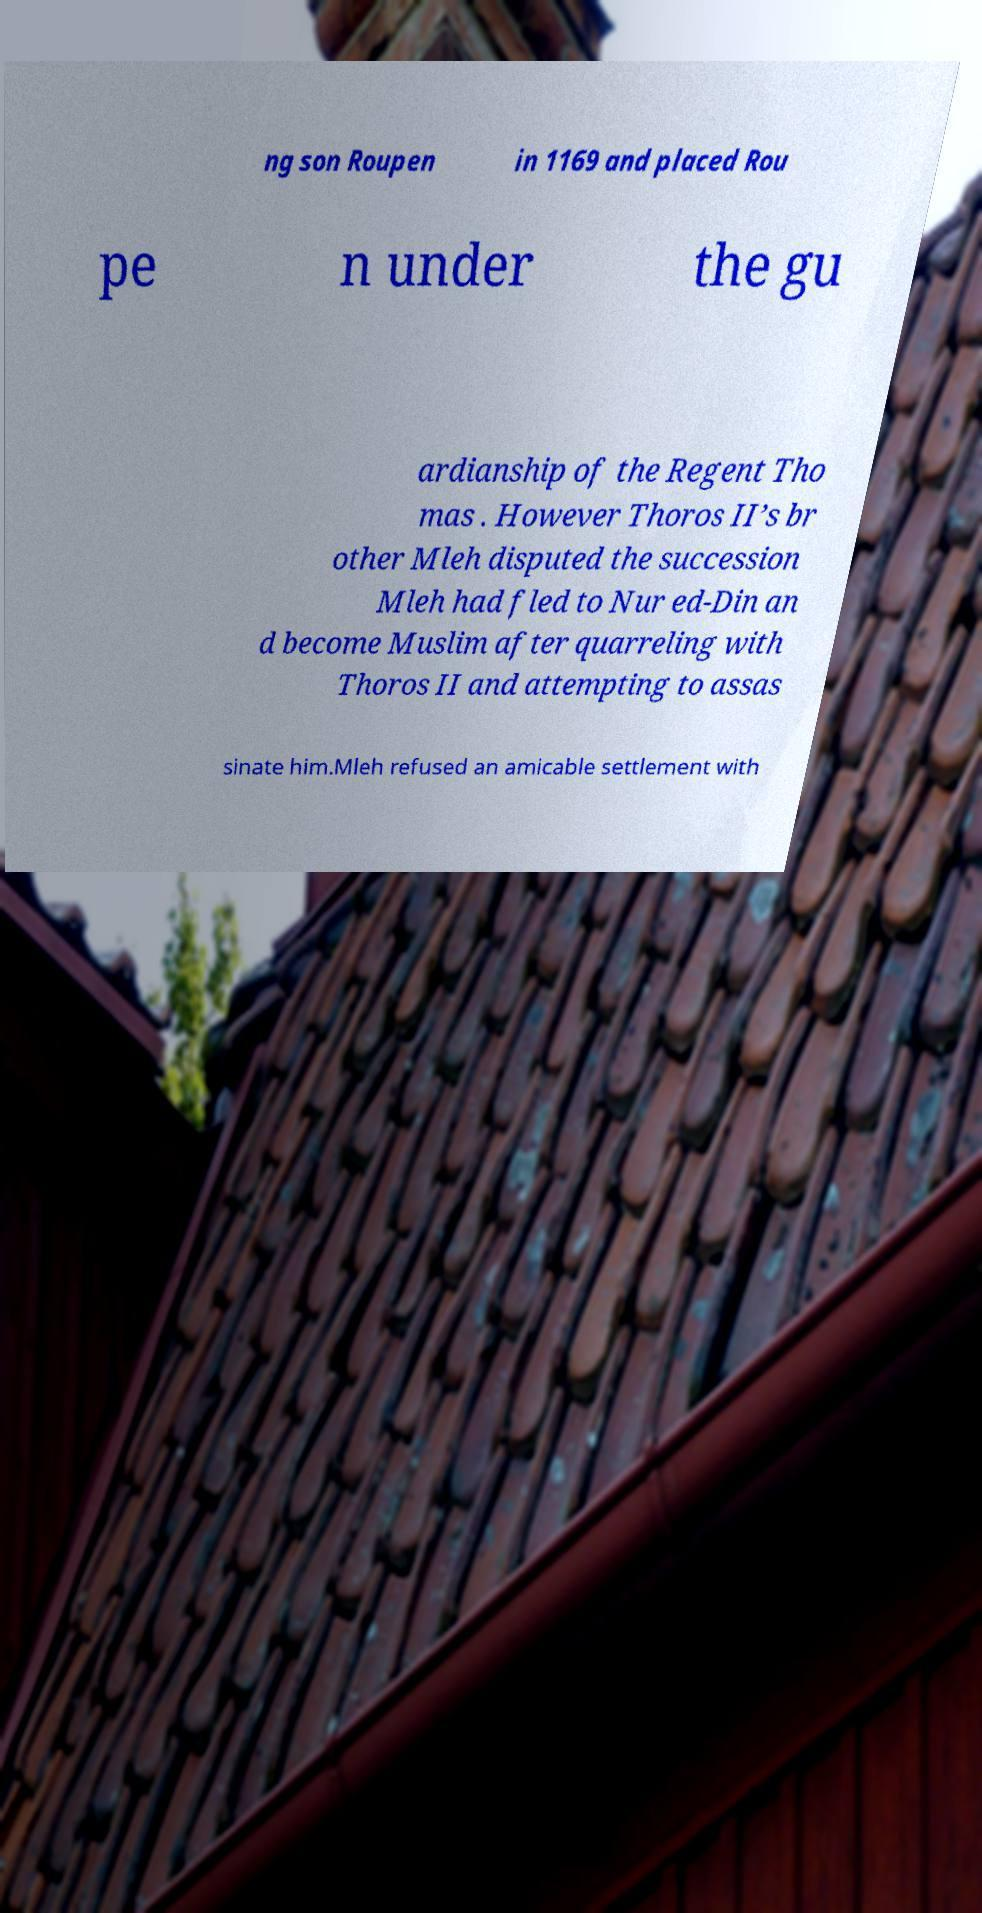What messages or text are displayed in this image? I need them in a readable, typed format. ng son Roupen in 1169 and placed Rou pe n under the gu ardianship of the Regent Tho mas . However Thoros II’s br other Mleh disputed the succession Mleh had fled to Nur ed-Din an d become Muslim after quarreling with Thoros II and attempting to assas sinate him.Mleh refused an amicable settlement with 